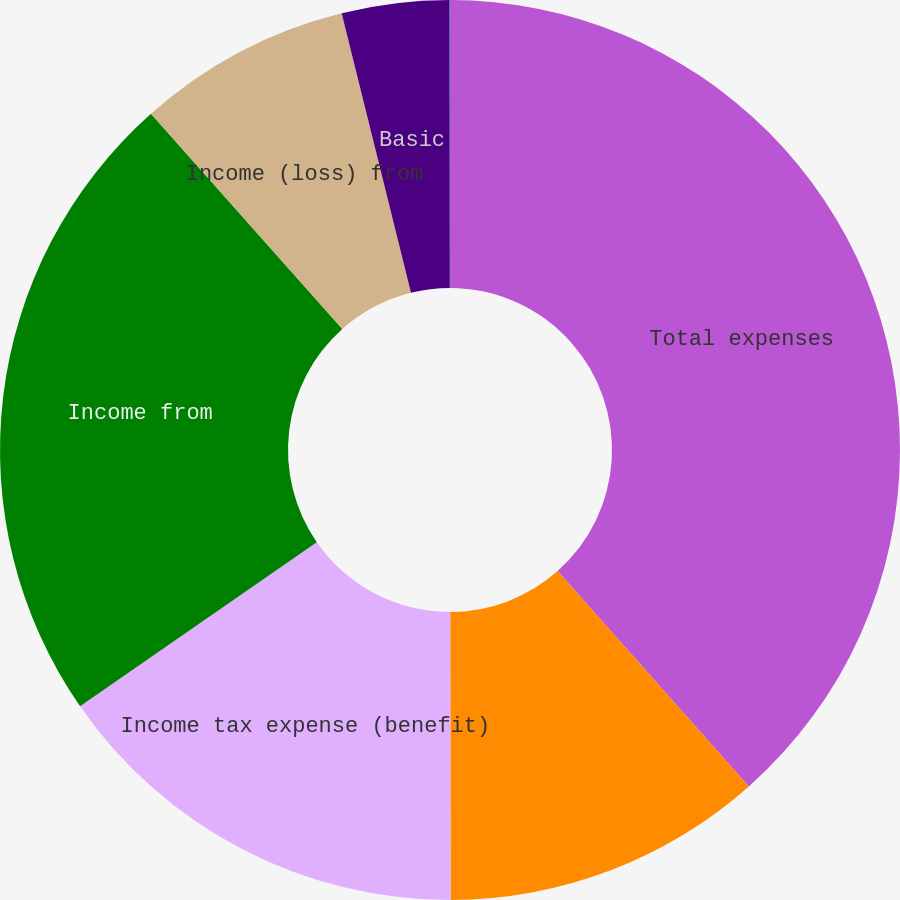Convert chart to OTSL. <chart><loc_0><loc_0><loc_500><loc_500><pie_chart><fcel>Total expenses<fcel>Income (loss) from continuing<fcel>Income tax expense (benefit)<fcel>Income from<fcel>Income (loss) from<fcel>Basic<fcel>Diluted<nl><fcel>38.44%<fcel>11.54%<fcel>15.38%<fcel>23.07%<fcel>7.7%<fcel>3.86%<fcel>0.01%<nl></chart> 